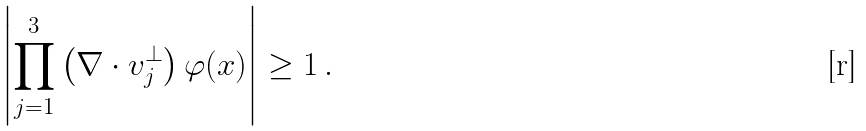Convert formula to latex. <formula><loc_0><loc_0><loc_500><loc_500>\left | \prod _ { j = 1 } ^ { 3 } \left ( \nabla \cdot { v } _ { j } ^ { \perp } \right ) \varphi ( { x } ) \right | \geq 1 \, .</formula> 